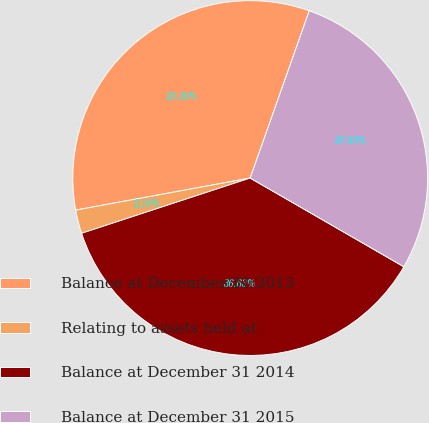Convert chart to OTSL. <chart><loc_0><loc_0><loc_500><loc_500><pie_chart><fcel>Balance at December 31 2013<fcel>Relating to assets held at<fcel>Balance at December 31 2014<fcel>Balance at December 31 2015<nl><fcel>33.3%<fcel>2.15%<fcel>36.63%<fcel>27.93%<nl></chart> 